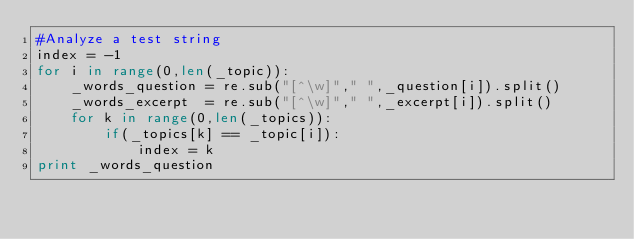Convert code to text. <code><loc_0><loc_0><loc_500><loc_500><_Python_>#Analyze a test string
index = -1
for i in range(0,len(_topic)):
    _words_question = re.sub("[^\w]"," ",_question[i]).split()
    _words_excerpt  = re.sub("[^\w]"," ",_excerpt[i]).split()
    for k in range(0,len(_topics)):
        if(_topics[k] == _topic[i]):
            index = k
print _words_question
</code> 